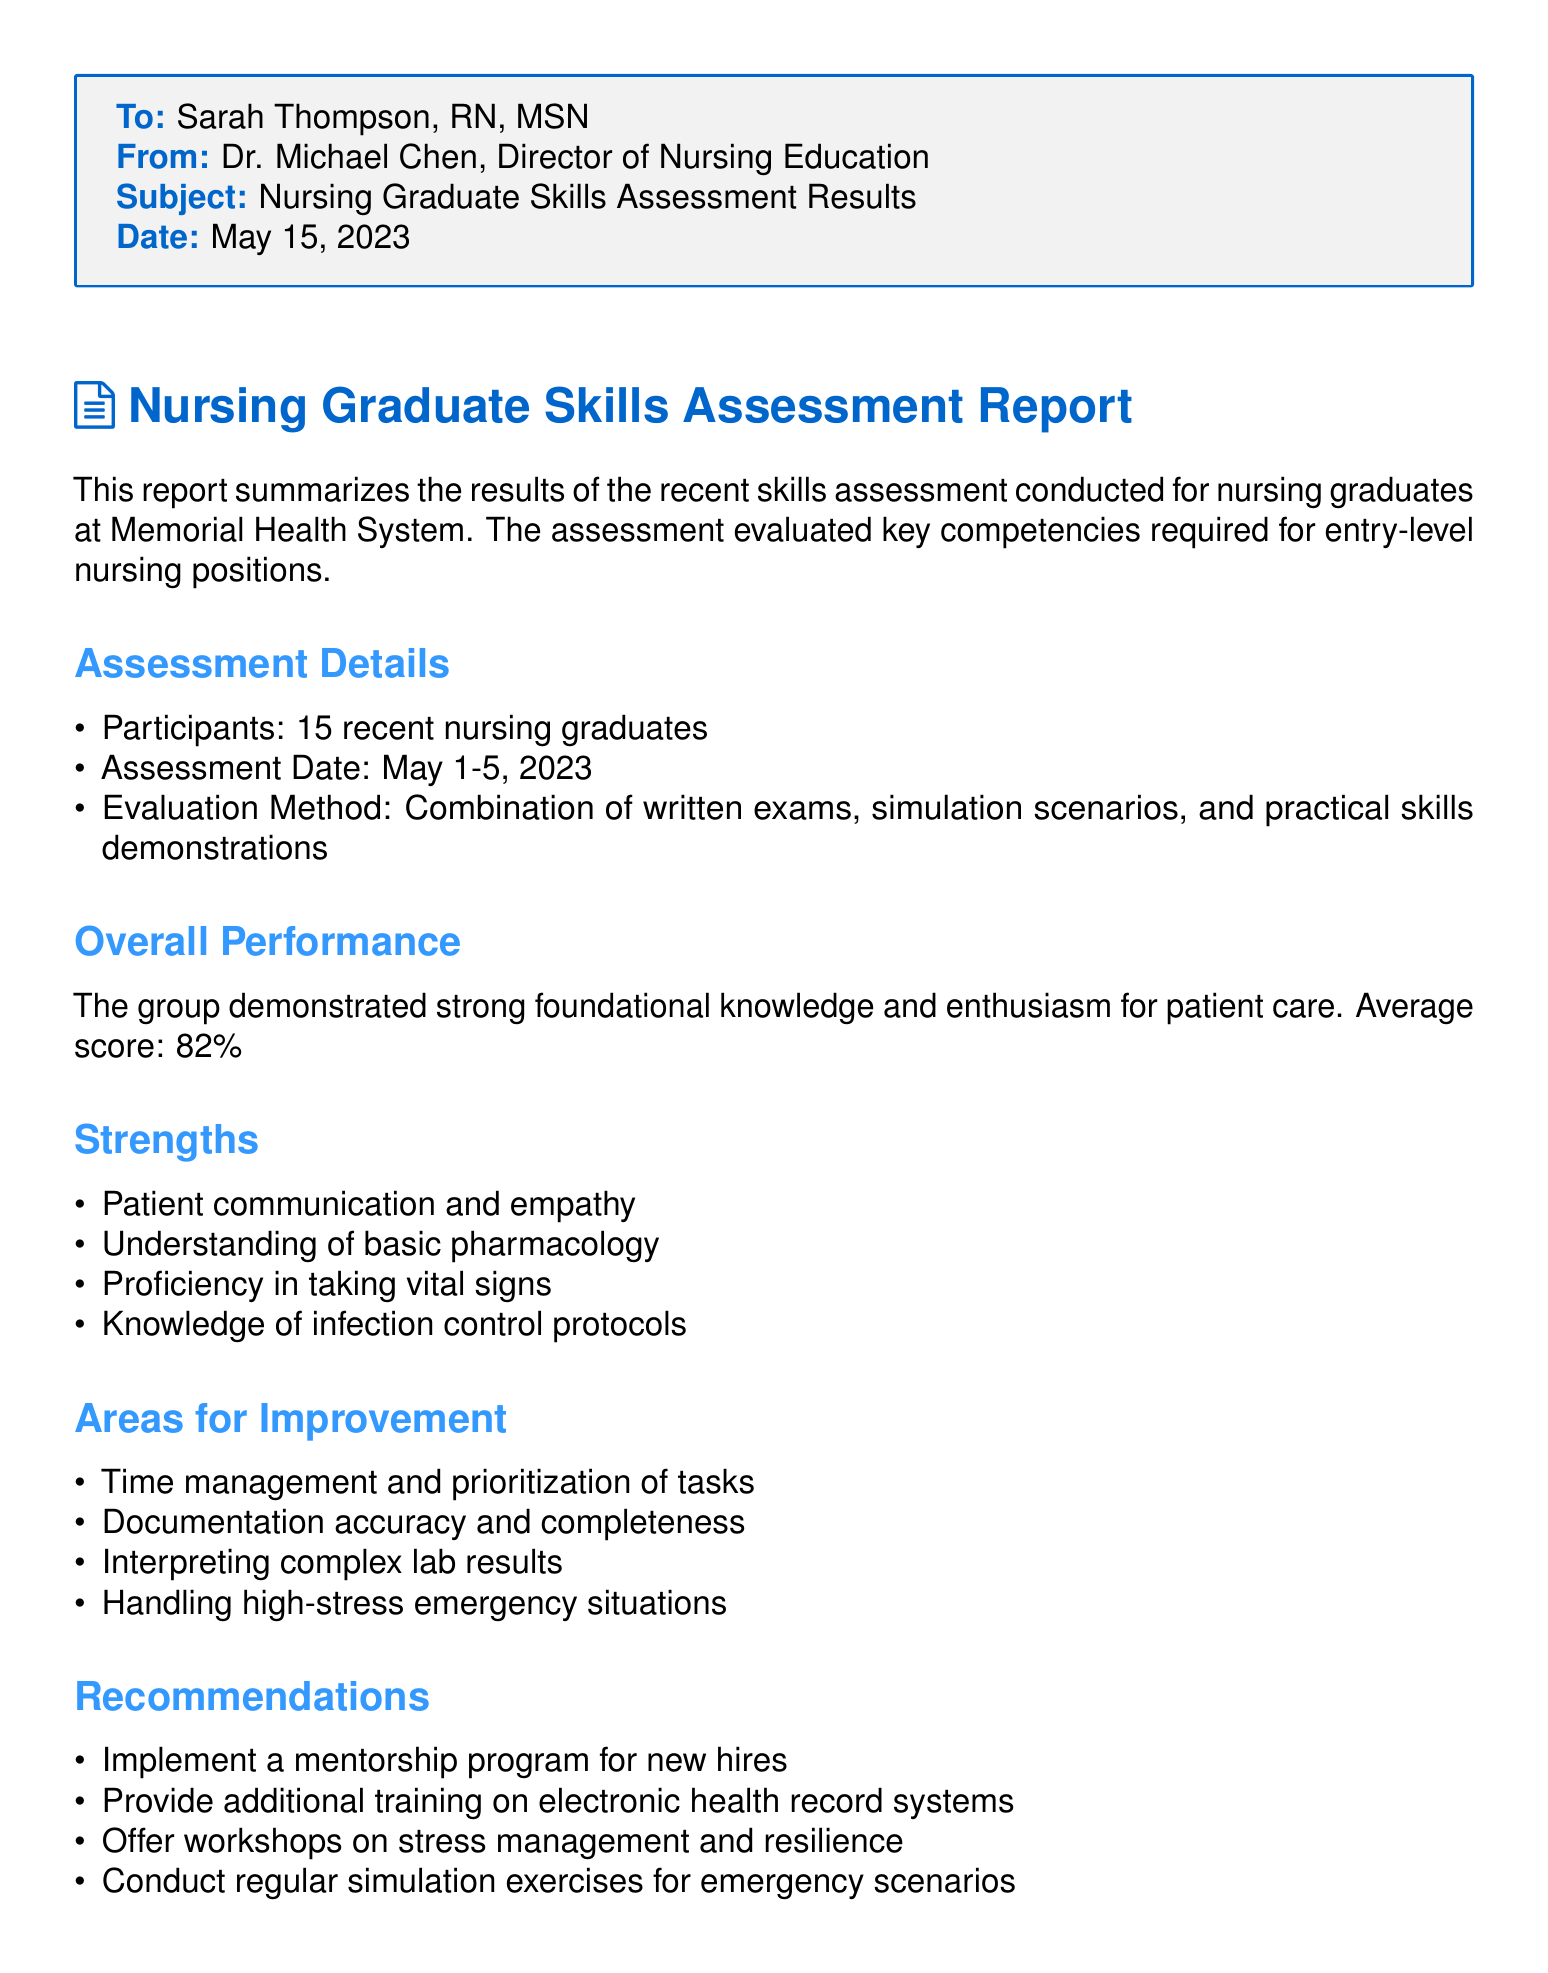what is the title of the document? The title describes the content of the document, which is the skills assessment results for nursing graduates.
Answer: Nursing Graduate Skills Assessment Report who conducted the assessment? The assessment was conducted by Dr. Michael Chen, who is the Director of Nursing Education.
Answer: Dr. Michael Chen how many nursing graduates participated in the assessment? The document states the total number of participants in the skills assessment.
Answer: 15 what was the average score of the assessment? The average score is mentioned as the performance metric of the group of nursing graduates.
Answer: 82% what was one identified strength of the nursing graduates? The document lists strengths observed during the assessment; one example can be cited from this list.
Answer: Patient communication and empathy name one area for improvement noted in the report. The report highlights areas where nursing graduates can improve; a specific area can be mentioned.
Answer: Time management and prioritization of tasks what date was the assessment conducted? The document specifies the range of dates when the assessment took place.
Answer: May 1-5, 2023 what recommendation was made regarding new hires? The conclusions include suggestions for enhancing the capability of new hires within the organization.
Answer: Implement a mentorship program for new hires what is the conclusion about the cohort of nursing graduates? The conclusion summarizes the overall assessment and future potential of the graduates.
Answer: Shows promise and potential for growth 